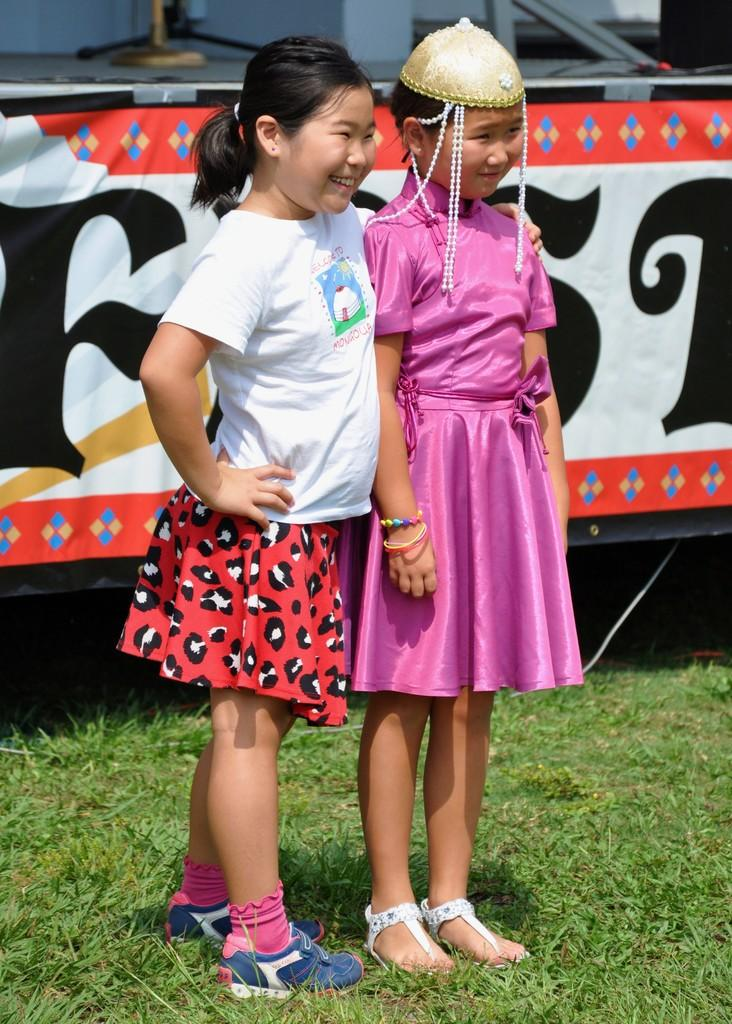How many people are in the image? There are two girls in the image. What is the surface the girls are standing on? The girls are standing on the grass. What can be seen in the background of the image? There is an advertisement visible in the background of the image. What type of bell can be heard ringing in the image? There is no bell present or ringing in the image. Can you tell me the color of the mailbox in the image? There is no mailbox present in the image. 